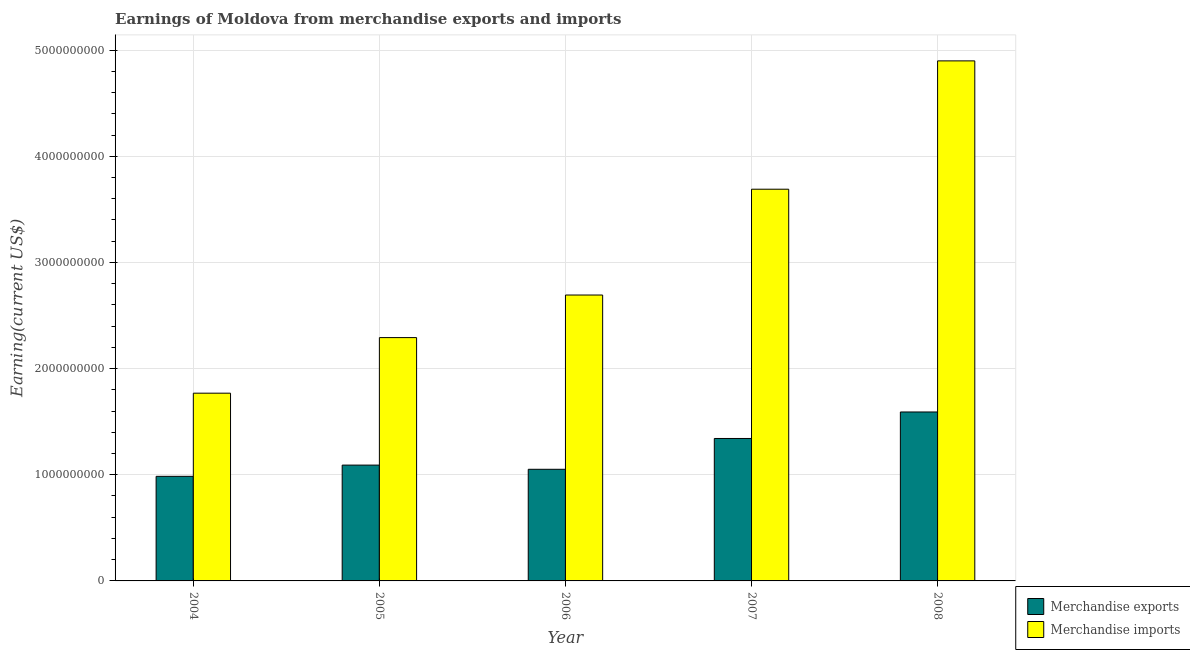How many groups of bars are there?
Your answer should be compact. 5. How many bars are there on the 4th tick from the right?
Your response must be concise. 2. In how many cases, is the number of bars for a given year not equal to the number of legend labels?
Ensure brevity in your answer.  0. What is the earnings from merchandise exports in 2007?
Provide a short and direct response. 1.34e+09. Across all years, what is the maximum earnings from merchandise imports?
Keep it short and to the point. 4.90e+09. Across all years, what is the minimum earnings from merchandise exports?
Give a very brief answer. 9.85e+08. What is the total earnings from merchandise imports in the graph?
Make the answer very short. 1.53e+1. What is the difference between the earnings from merchandise exports in 2006 and that in 2008?
Make the answer very short. -5.40e+08. What is the difference between the earnings from merchandise imports in 2004 and the earnings from merchandise exports in 2008?
Ensure brevity in your answer.  -3.13e+09. What is the average earnings from merchandise exports per year?
Your answer should be compact. 1.21e+09. In the year 2007, what is the difference between the earnings from merchandise imports and earnings from merchandise exports?
Give a very brief answer. 0. What is the ratio of the earnings from merchandise imports in 2004 to that in 2006?
Offer a very short reply. 0.66. Is the earnings from merchandise exports in 2005 less than that in 2008?
Provide a succinct answer. Yes. Is the difference between the earnings from merchandise imports in 2006 and 2007 greater than the difference between the earnings from merchandise exports in 2006 and 2007?
Offer a terse response. No. What is the difference between the highest and the second highest earnings from merchandise imports?
Provide a succinct answer. 1.21e+09. What is the difference between the highest and the lowest earnings from merchandise exports?
Provide a short and direct response. 6.06e+08. Are all the bars in the graph horizontal?
Your answer should be compact. No. Does the graph contain any zero values?
Your answer should be very brief. No. Does the graph contain grids?
Your answer should be compact. Yes. Where does the legend appear in the graph?
Provide a short and direct response. Bottom right. How many legend labels are there?
Ensure brevity in your answer.  2. What is the title of the graph?
Provide a succinct answer. Earnings of Moldova from merchandise exports and imports. What is the label or title of the Y-axis?
Offer a terse response. Earning(current US$). What is the Earning(current US$) in Merchandise exports in 2004?
Make the answer very short. 9.85e+08. What is the Earning(current US$) in Merchandise imports in 2004?
Provide a short and direct response. 1.77e+09. What is the Earning(current US$) in Merchandise exports in 2005?
Keep it short and to the point. 1.09e+09. What is the Earning(current US$) of Merchandise imports in 2005?
Your answer should be compact. 2.29e+09. What is the Earning(current US$) of Merchandise exports in 2006?
Offer a terse response. 1.05e+09. What is the Earning(current US$) of Merchandise imports in 2006?
Your answer should be very brief. 2.69e+09. What is the Earning(current US$) in Merchandise exports in 2007?
Your answer should be compact. 1.34e+09. What is the Earning(current US$) of Merchandise imports in 2007?
Offer a terse response. 3.69e+09. What is the Earning(current US$) of Merchandise exports in 2008?
Make the answer very short. 1.59e+09. What is the Earning(current US$) in Merchandise imports in 2008?
Provide a short and direct response. 4.90e+09. Across all years, what is the maximum Earning(current US$) of Merchandise exports?
Make the answer very short. 1.59e+09. Across all years, what is the maximum Earning(current US$) of Merchandise imports?
Your answer should be compact. 4.90e+09. Across all years, what is the minimum Earning(current US$) of Merchandise exports?
Your response must be concise. 9.85e+08. Across all years, what is the minimum Earning(current US$) of Merchandise imports?
Your answer should be very brief. 1.77e+09. What is the total Earning(current US$) of Merchandise exports in the graph?
Your answer should be very brief. 6.06e+09. What is the total Earning(current US$) in Merchandise imports in the graph?
Offer a very short reply. 1.53e+1. What is the difference between the Earning(current US$) of Merchandise exports in 2004 and that in 2005?
Make the answer very short. -1.06e+08. What is the difference between the Earning(current US$) in Merchandise imports in 2004 and that in 2005?
Your response must be concise. -5.23e+08. What is the difference between the Earning(current US$) in Merchandise exports in 2004 and that in 2006?
Your response must be concise. -6.64e+07. What is the difference between the Earning(current US$) in Merchandise imports in 2004 and that in 2006?
Your response must be concise. -9.25e+08. What is the difference between the Earning(current US$) in Merchandise exports in 2004 and that in 2007?
Offer a very short reply. -3.57e+08. What is the difference between the Earning(current US$) of Merchandise imports in 2004 and that in 2007?
Provide a succinct answer. -1.92e+09. What is the difference between the Earning(current US$) of Merchandise exports in 2004 and that in 2008?
Ensure brevity in your answer.  -6.06e+08. What is the difference between the Earning(current US$) of Merchandise imports in 2004 and that in 2008?
Offer a terse response. -3.13e+09. What is the difference between the Earning(current US$) in Merchandise exports in 2005 and that in 2006?
Your answer should be compact. 3.94e+07. What is the difference between the Earning(current US$) in Merchandise imports in 2005 and that in 2006?
Ensure brevity in your answer.  -4.01e+08. What is the difference between the Earning(current US$) in Merchandise exports in 2005 and that in 2007?
Your answer should be compact. -2.51e+08. What is the difference between the Earning(current US$) of Merchandise imports in 2005 and that in 2007?
Ensure brevity in your answer.  -1.40e+09. What is the difference between the Earning(current US$) of Merchandise exports in 2005 and that in 2008?
Make the answer very short. -5.00e+08. What is the difference between the Earning(current US$) of Merchandise imports in 2005 and that in 2008?
Keep it short and to the point. -2.61e+09. What is the difference between the Earning(current US$) in Merchandise exports in 2006 and that in 2007?
Make the answer very short. -2.90e+08. What is the difference between the Earning(current US$) of Merchandise imports in 2006 and that in 2007?
Your answer should be compact. -9.97e+08. What is the difference between the Earning(current US$) in Merchandise exports in 2006 and that in 2008?
Your response must be concise. -5.40e+08. What is the difference between the Earning(current US$) of Merchandise imports in 2006 and that in 2008?
Ensure brevity in your answer.  -2.21e+09. What is the difference between the Earning(current US$) of Merchandise exports in 2007 and that in 2008?
Give a very brief answer. -2.50e+08. What is the difference between the Earning(current US$) of Merchandise imports in 2007 and that in 2008?
Give a very brief answer. -1.21e+09. What is the difference between the Earning(current US$) of Merchandise exports in 2004 and the Earning(current US$) of Merchandise imports in 2005?
Your answer should be very brief. -1.31e+09. What is the difference between the Earning(current US$) in Merchandise exports in 2004 and the Earning(current US$) in Merchandise imports in 2006?
Keep it short and to the point. -1.71e+09. What is the difference between the Earning(current US$) of Merchandise exports in 2004 and the Earning(current US$) of Merchandise imports in 2007?
Your answer should be compact. -2.70e+09. What is the difference between the Earning(current US$) in Merchandise exports in 2004 and the Earning(current US$) in Merchandise imports in 2008?
Provide a succinct answer. -3.91e+09. What is the difference between the Earning(current US$) of Merchandise exports in 2005 and the Earning(current US$) of Merchandise imports in 2006?
Keep it short and to the point. -1.60e+09. What is the difference between the Earning(current US$) in Merchandise exports in 2005 and the Earning(current US$) in Merchandise imports in 2007?
Give a very brief answer. -2.60e+09. What is the difference between the Earning(current US$) in Merchandise exports in 2005 and the Earning(current US$) in Merchandise imports in 2008?
Provide a succinct answer. -3.81e+09. What is the difference between the Earning(current US$) in Merchandise exports in 2006 and the Earning(current US$) in Merchandise imports in 2007?
Make the answer very short. -2.64e+09. What is the difference between the Earning(current US$) in Merchandise exports in 2006 and the Earning(current US$) in Merchandise imports in 2008?
Provide a succinct answer. -3.85e+09. What is the difference between the Earning(current US$) of Merchandise exports in 2007 and the Earning(current US$) of Merchandise imports in 2008?
Offer a very short reply. -3.56e+09. What is the average Earning(current US$) of Merchandise exports per year?
Your answer should be compact. 1.21e+09. What is the average Earning(current US$) of Merchandise imports per year?
Keep it short and to the point. 3.07e+09. In the year 2004, what is the difference between the Earning(current US$) in Merchandise exports and Earning(current US$) in Merchandise imports?
Your response must be concise. -7.83e+08. In the year 2005, what is the difference between the Earning(current US$) in Merchandise exports and Earning(current US$) in Merchandise imports?
Your answer should be very brief. -1.20e+09. In the year 2006, what is the difference between the Earning(current US$) in Merchandise exports and Earning(current US$) in Merchandise imports?
Give a very brief answer. -1.64e+09. In the year 2007, what is the difference between the Earning(current US$) in Merchandise exports and Earning(current US$) in Merchandise imports?
Your response must be concise. -2.35e+09. In the year 2008, what is the difference between the Earning(current US$) in Merchandise exports and Earning(current US$) in Merchandise imports?
Make the answer very short. -3.31e+09. What is the ratio of the Earning(current US$) in Merchandise exports in 2004 to that in 2005?
Keep it short and to the point. 0.9. What is the ratio of the Earning(current US$) in Merchandise imports in 2004 to that in 2005?
Ensure brevity in your answer.  0.77. What is the ratio of the Earning(current US$) of Merchandise exports in 2004 to that in 2006?
Ensure brevity in your answer.  0.94. What is the ratio of the Earning(current US$) in Merchandise imports in 2004 to that in 2006?
Provide a succinct answer. 0.66. What is the ratio of the Earning(current US$) in Merchandise exports in 2004 to that in 2007?
Make the answer very short. 0.73. What is the ratio of the Earning(current US$) of Merchandise imports in 2004 to that in 2007?
Your answer should be very brief. 0.48. What is the ratio of the Earning(current US$) of Merchandise exports in 2004 to that in 2008?
Your answer should be very brief. 0.62. What is the ratio of the Earning(current US$) in Merchandise imports in 2004 to that in 2008?
Provide a succinct answer. 0.36. What is the ratio of the Earning(current US$) of Merchandise exports in 2005 to that in 2006?
Provide a short and direct response. 1.04. What is the ratio of the Earning(current US$) in Merchandise imports in 2005 to that in 2006?
Offer a terse response. 0.85. What is the ratio of the Earning(current US$) in Merchandise exports in 2005 to that in 2007?
Your answer should be very brief. 0.81. What is the ratio of the Earning(current US$) of Merchandise imports in 2005 to that in 2007?
Keep it short and to the point. 0.62. What is the ratio of the Earning(current US$) of Merchandise exports in 2005 to that in 2008?
Offer a terse response. 0.69. What is the ratio of the Earning(current US$) of Merchandise imports in 2005 to that in 2008?
Your response must be concise. 0.47. What is the ratio of the Earning(current US$) of Merchandise exports in 2006 to that in 2007?
Your answer should be compact. 0.78. What is the ratio of the Earning(current US$) of Merchandise imports in 2006 to that in 2007?
Give a very brief answer. 0.73. What is the ratio of the Earning(current US$) in Merchandise exports in 2006 to that in 2008?
Offer a terse response. 0.66. What is the ratio of the Earning(current US$) in Merchandise imports in 2006 to that in 2008?
Make the answer very short. 0.55. What is the ratio of the Earning(current US$) in Merchandise exports in 2007 to that in 2008?
Keep it short and to the point. 0.84. What is the ratio of the Earning(current US$) of Merchandise imports in 2007 to that in 2008?
Your response must be concise. 0.75. What is the difference between the highest and the second highest Earning(current US$) of Merchandise exports?
Make the answer very short. 2.50e+08. What is the difference between the highest and the second highest Earning(current US$) of Merchandise imports?
Offer a terse response. 1.21e+09. What is the difference between the highest and the lowest Earning(current US$) in Merchandise exports?
Ensure brevity in your answer.  6.06e+08. What is the difference between the highest and the lowest Earning(current US$) in Merchandise imports?
Provide a short and direct response. 3.13e+09. 